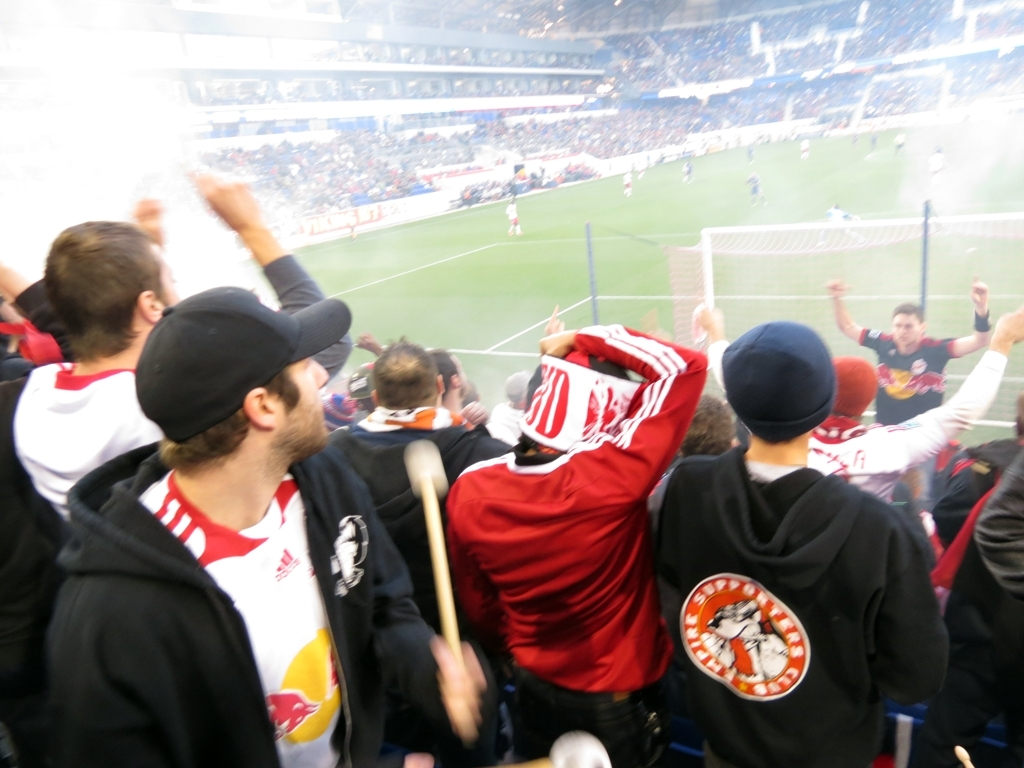Is the focusing issue affecting the image quality? Yes, the image quality is compromised due to a focusing issue, which results in a blurred scene where details are lost, particularly noticeable in the background where specific features of the action are difficult to discern. 